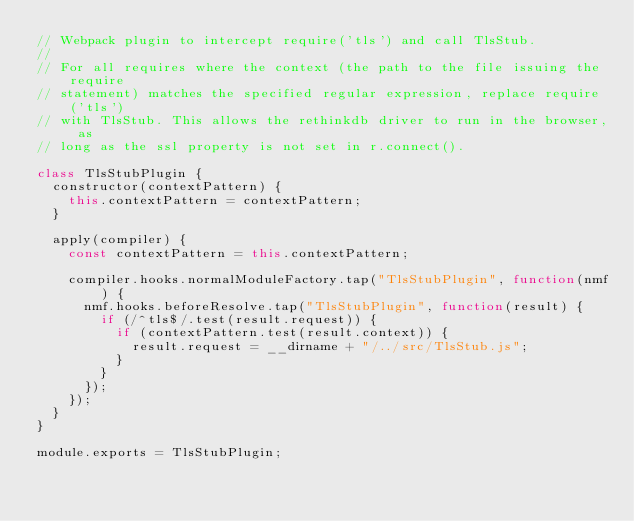<code> <loc_0><loc_0><loc_500><loc_500><_JavaScript_>// Webpack plugin to intercept require('tls') and call TlsStub.
//
// For all requires where the context (the path to the file issuing the require
// statement) matches the specified regular expression, replace require('tls')
// with TlsStub. This allows the rethinkdb driver to run in the browser, as
// long as the ssl property is not set in r.connect().

class TlsStubPlugin {
  constructor(contextPattern) {
    this.contextPattern = contextPattern;
  }

  apply(compiler) {
    const contextPattern = this.contextPattern;

    compiler.hooks.normalModuleFactory.tap("TlsStubPlugin", function(nmf) {
      nmf.hooks.beforeResolve.tap("TlsStubPlugin", function(result) {
        if (/^tls$/.test(result.request)) {
          if (contextPattern.test(result.context)) {
            result.request = __dirname + "/../src/TlsStub.js";
          }
        }
      });
    });
  }
}

module.exports = TlsStubPlugin;
</code> 